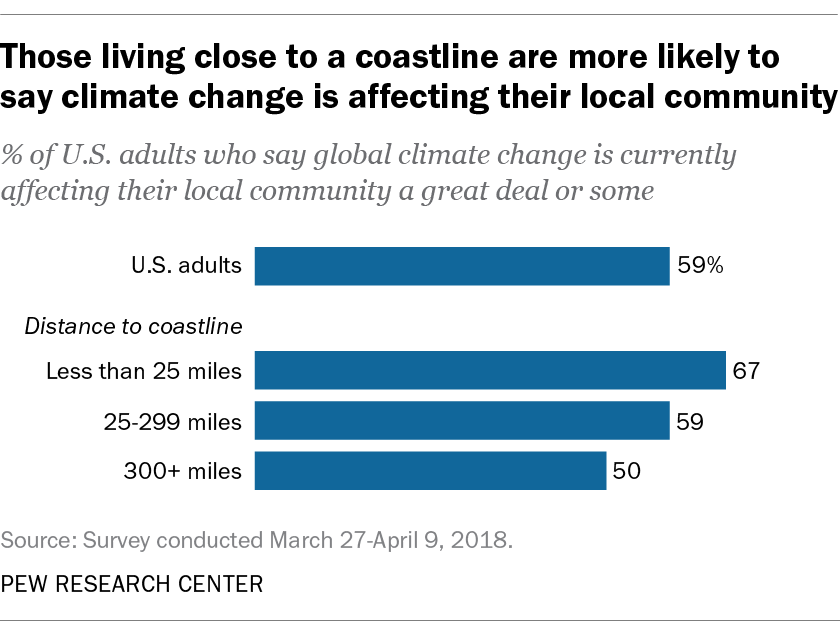Give some essential details in this illustration. The second blue bar from the bottom has a value of 59. 